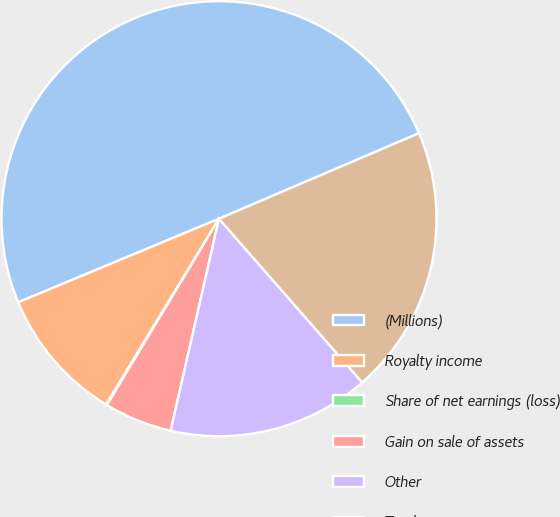Convert chart to OTSL. <chart><loc_0><loc_0><loc_500><loc_500><pie_chart><fcel>(Millions)<fcel>Royalty income<fcel>Share of net earnings (loss)<fcel>Gain on sale of assets<fcel>Other<fcel>Total<nl><fcel>49.85%<fcel>10.03%<fcel>0.07%<fcel>5.05%<fcel>15.01%<fcel>19.99%<nl></chart> 